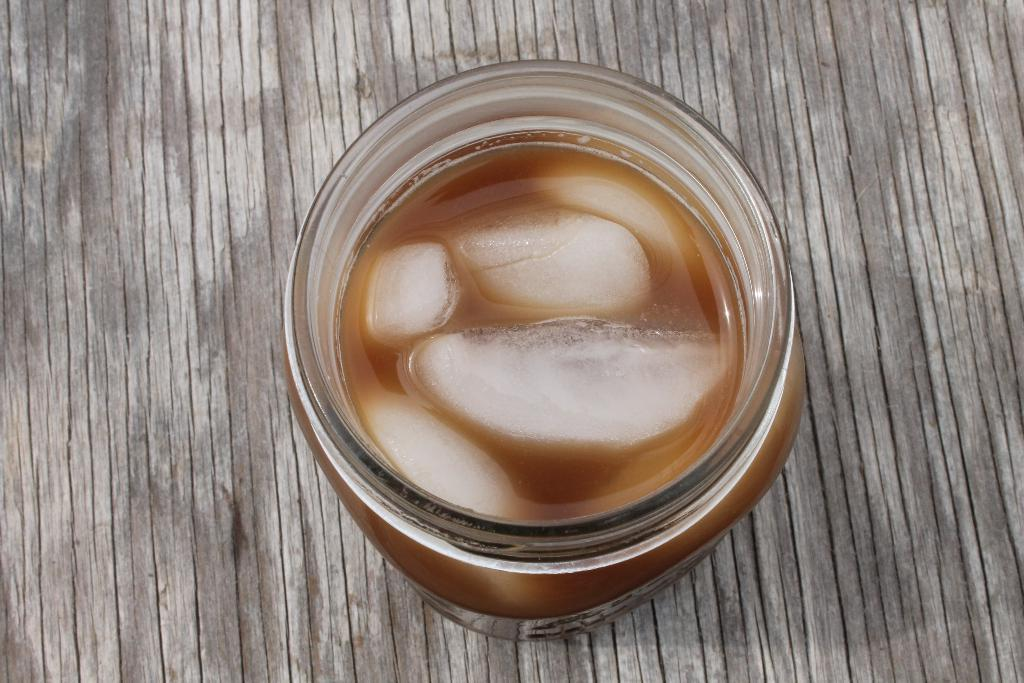What is inside the bottle that is visible in the image? There is a food item in a bottle. Where is the bottle located in the image? The bottle is on a wooden surface. How does the brick in the image contribute to the conversation? There is no brick present in the image, so it cannot contribute to the conversation. 